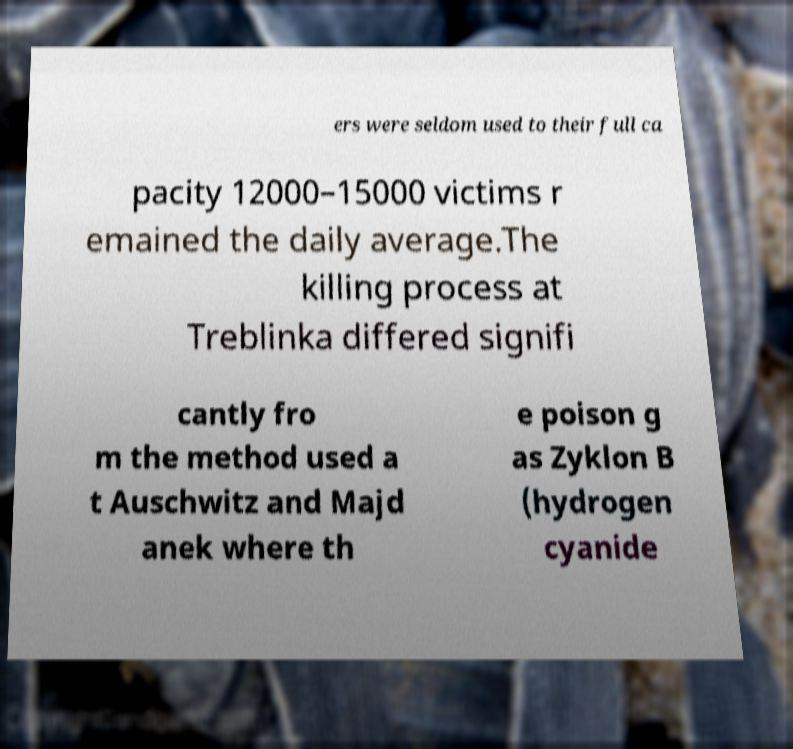I need the written content from this picture converted into text. Can you do that? ers were seldom used to their full ca pacity 12000–15000 victims r emained the daily average.The killing process at Treblinka differed signifi cantly fro m the method used a t Auschwitz and Majd anek where th e poison g as Zyklon B (hydrogen cyanide 